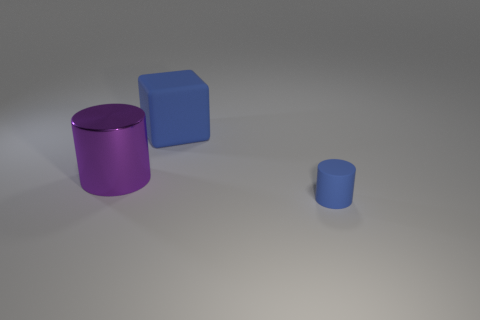Is there any other thing that has the same material as the purple cylinder?
Keep it short and to the point. No. What is the large object behind the big purple metal cylinder made of?
Provide a succinct answer. Rubber. The big matte thing that is the same color as the tiny object is what shape?
Your answer should be compact. Cube. Is there a small purple ball made of the same material as the tiny cylinder?
Your answer should be compact. No. The cube has what size?
Keep it short and to the point. Large. What number of purple objects are either large rubber things or large cylinders?
Provide a succinct answer. 1. What number of other big metal objects are the same shape as the large purple thing?
Keep it short and to the point. 0. What number of blue blocks are the same size as the purple cylinder?
Offer a very short reply. 1. What is the material of the other object that is the same shape as the purple thing?
Keep it short and to the point. Rubber. What color is the matte thing behind the small rubber thing?
Ensure brevity in your answer.  Blue. 